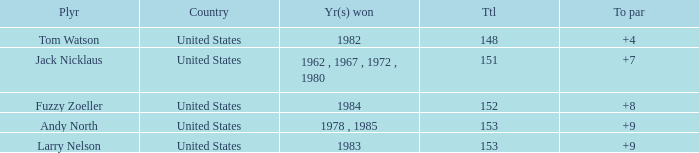What is the Country of the Player with a Total less than 153 and Year(s) won of 1984? United States. 